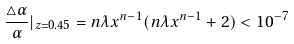<formula> <loc_0><loc_0><loc_500><loc_500>\frac { \triangle \alpha } { \alpha } | _ { z = 0 . 4 5 } = n \lambda x ^ { n - 1 } ( n \lambda x ^ { n - 1 } + 2 ) < 1 0 ^ { - 7 }</formula> 